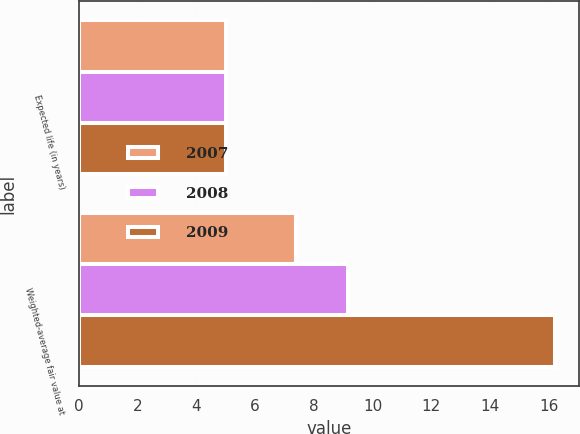Convert chart. <chart><loc_0><loc_0><loc_500><loc_500><stacked_bar_chart><ecel><fcel>Expected life (in years)<fcel>Weighted-average fair value at<nl><fcel>2007<fcel>5<fcel>7.4<nl><fcel>2008<fcel>5<fcel>9.17<nl><fcel>2009<fcel>5<fcel>16.22<nl></chart> 